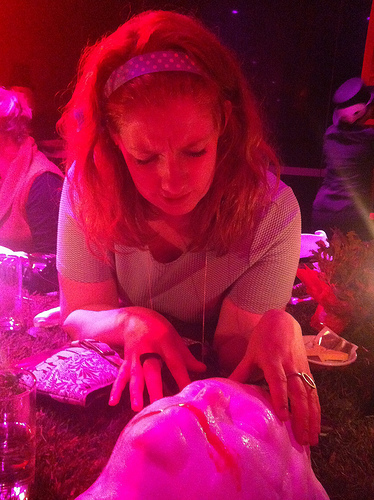<image>
Is there a girl above the plate? No. The girl is not positioned above the plate. The vertical arrangement shows a different relationship. 